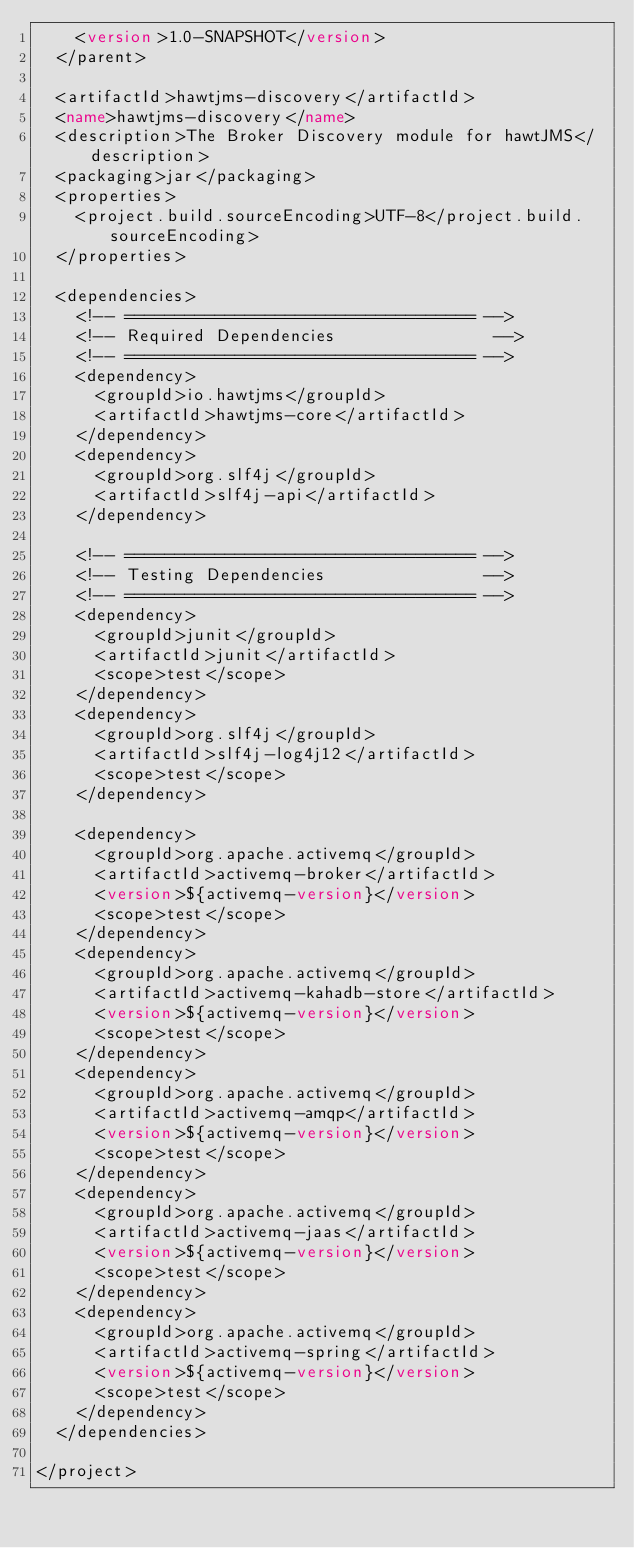Convert code to text. <code><loc_0><loc_0><loc_500><loc_500><_XML_>    <version>1.0-SNAPSHOT</version>
  </parent>

  <artifactId>hawtjms-discovery</artifactId>
  <name>hawtjms-discovery</name>
  <description>The Broker Discovery module for hawtJMS</description>
  <packaging>jar</packaging>
  <properties>
    <project.build.sourceEncoding>UTF-8</project.build.sourceEncoding>
  </properties>

  <dependencies>
    <!-- =================================== -->
    <!-- Required Dependencies                -->
    <!-- =================================== -->
    <dependency>
      <groupId>io.hawtjms</groupId>
      <artifactId>hawtjms-core</artifactId>
    </dependency>
    <dependency>
      <groupId>org.slf4j</groupId>
      <artifactId>slf4j-api</artifactId>
    </dependency>

    <!-- =================================== -->
    <!-- Testing Dependencies                -->
    <!-- =================================== -->
    <dependency>
      <groupId>junit</groupId>
      <artifactId>junit</artifactId>
      <scope>test</scope>
    </dependency>
    <dependency>
      <groupId>org.slf4j</groupId>
      <artifactId>slf4j-log4j12</artifactId>
      <scope>test</scope>
    </dependency>

    <dependency>
      <groupId>org.apache.activemq</groupId>
      <artifactId>activemq-broker</artifactId>
      <version>${activemq-version}</version>
      <scope>test</scope>
    </dependency>
    <dependency>
      <groupId>org.apache.activemq</groupId>
      <artifactId>activemq-kahadb-store</artifactId>
      <version>${activemq-version}</version>
      <scope>test</scope>
    </dependency>
    <dependency>
      <groupId>org.apache.activemq</groupId>
      <artifactId>activemq-amqp</artifactId>
      <version>${activemq-version}</version>
      <scope>test</scope>
    </dependency>
    <dependency>
      <groupId>org.apache.activemq</groupId>
      <artifactId>activemq-jaas</artifactId>
      <version>${activemq-version}</version>
      <scope>test</scope>
    </dependency>
    <dependency>
      <groupId>org.apache.activemq</groupId>
      <artifactId>activemq-spring</artifactId>
      <version>${activemq-version}</version>
      <scope>test</scope>
    </dependency>
  </dependencies>

</project>
</code> 